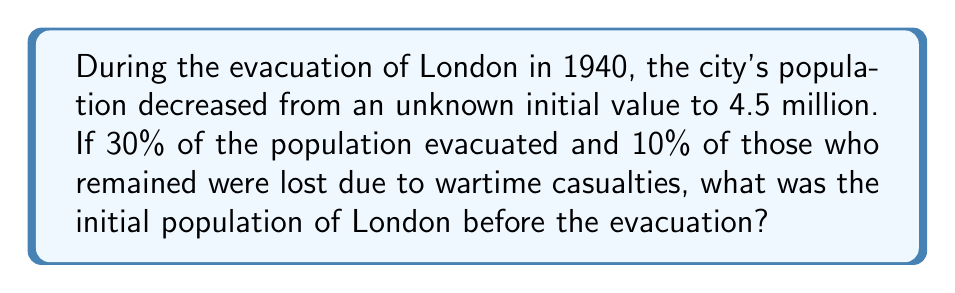Give your solution to this math problem. Let's approach this step-by-step:

1) Let $x$ be the initial population of London.

2) After the evacuation, 70% of the population remained:
   $0.7x$

3) Of those who remained, 90% survived the wartime casualties:
   $0.9(0.7x) = 0.63x$

4) We know this final population is 4.5 million:
   $0.63x = 4.5$ million

5) To solve for $x$, divide both sides by 0.63:
   $x = \frac{4.5}{0.63} = 7.14285714$ million

6) Rounding to the nearest hundred thousand:
   $x \approx 7.1$ million
Answer: 7.1 million 